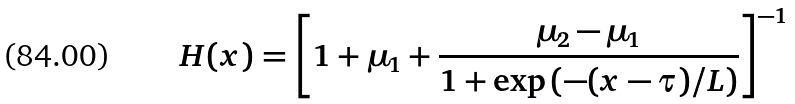<formula> <loc_0><loc_0><loc_500><loc_500>H ( x ) = \left [ 1 + \mu _ { 1 } + \frac { \mu _ { 2 } - \mu _ { 1 } } { 1 + \exp \left ( - ( x - \tau ) / L \right ) } \right ] ^ { - 1 }</formula> 